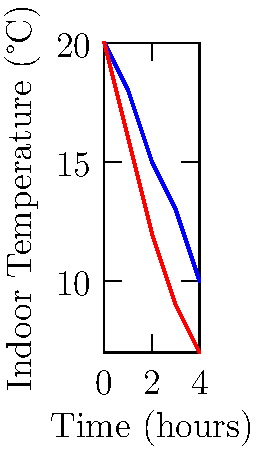The heat loss diagram shows the indoor temperature change over time for two building designs. If the outdoor temperature is 5°C, which design would be more suitable for a sensory-friendly environment for a child with autism, and why? To determine which design is more suitable for a sensory-friendly environment for a child with autism, we need to consider the following steps:

1. Analyze the temperature change:
   - Traditional Design (blue): Starts at 20°C and drops to 10°C over 4 hours
   - Energy-Efficient Design (red): Starts at 20°C and drops to 7°C over 4 hours

2. Calculate the temperature difference from the outdoor temperature (5°C):
   - Traditional Design: 10°C - 5°C = 5°C difference at 4 hours
   - Energy-Efficient Design: 7°C - 5°C = 2°C difference at 4 hours

3. Consider the impact on sensory sensitivity:
   - Children with autism often have sensory sensitivities, including temperature
   - A more stable temperature environment is generally better for reducing sensory overload

4. Evaluate temperature stability:
   - Traditional Design: Loses heat more slowly, maintaining a higher temperature
   - Energy-Efficient Design: Loses heat more quickly, approaching outdoor temperature

5. Consider energy efficiency:
   - While the Energy-Efficient Design loses heat faster, it would require less energy to maintain a consistent temperature due to better insulation

Given these factors, the Traditional Design (blue line) would be more suitable for a sensory-friendly environment because:
   a) It maintains a more stable and comfortable temperature over time
   b) The slower rate of heat loss means fewer fluctuations in temperature, which can be beneficial for a child with sensory sensitivities
   c) The higher indoor temperature provides a greater buffer from the cold outdoor temperature, potentially reducing thermal discomfort

While the Energy-Efficient Design might be better for overall energy consumption, the Traditional Design offers a more consistent sensory experience, which is crucial for a child with autism.
Answer: Traditional Design (blue line), due to more stable temperature over time 